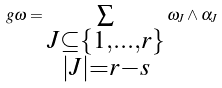Convert formula to latex. <formula><loc_0><loc_0><loc_500><loc_500>g \omega = \sum _ { \substack { J \subseteq \{ 1 , \dots , r \} \\ | J | = r - s } } \omega _ { J } \wedge \alpha _ { J }</formula> 